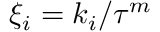<formula> <loc_0><loc_0><loc_500><loc_500>\xi _ { i } = k _ { i } / \tau ^ { m }</formula> 